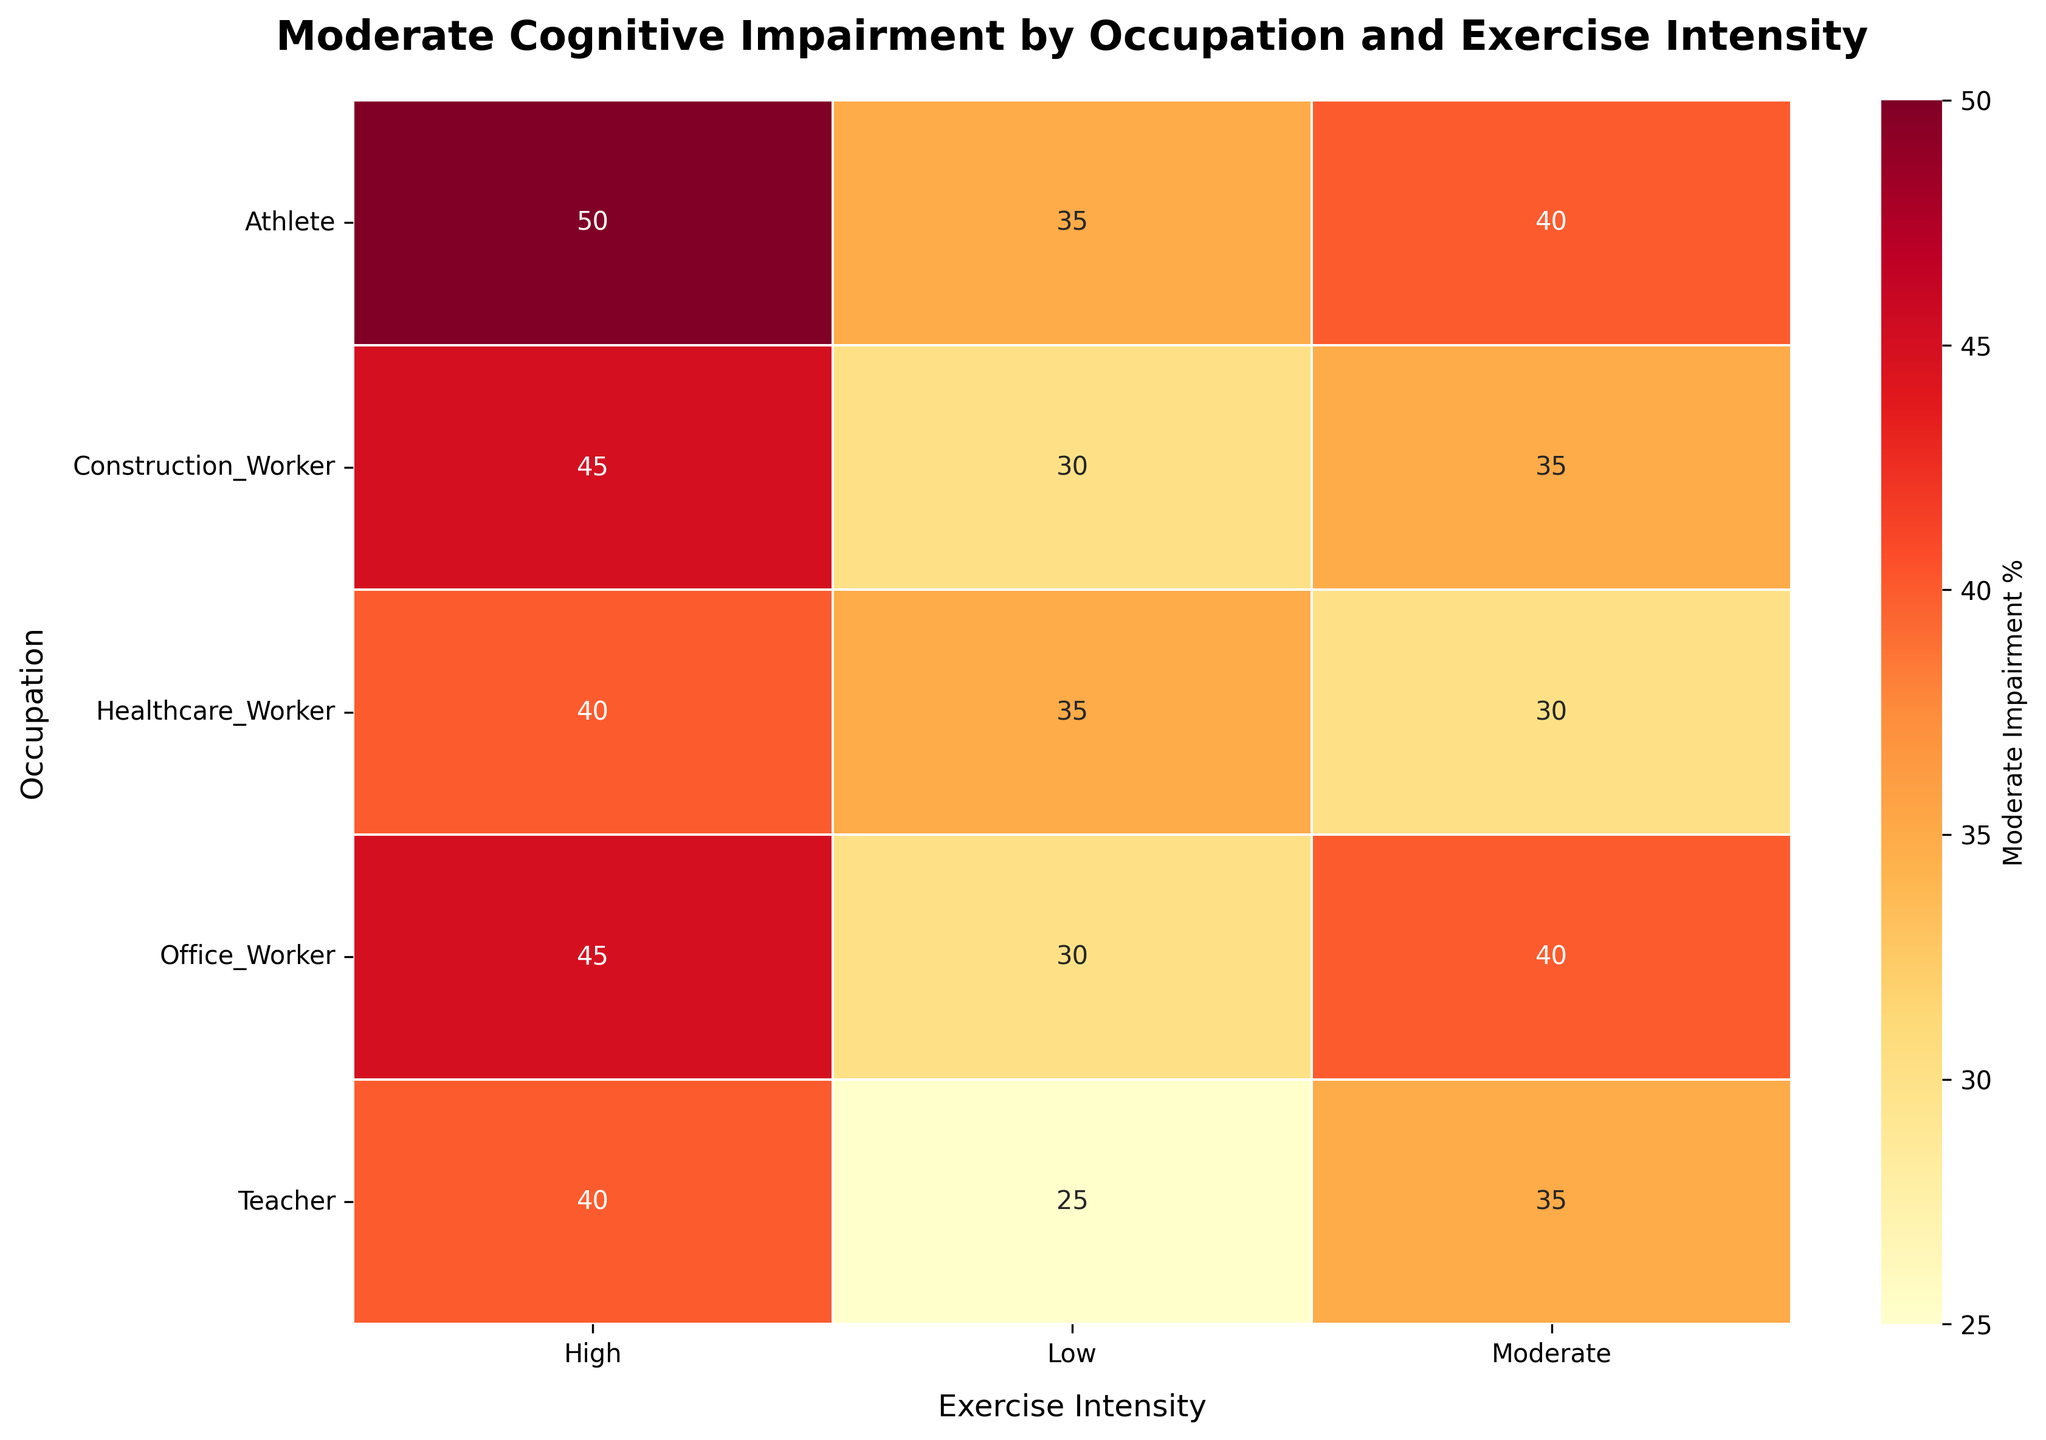what is the title of the heatmap? The title can be found at the top of the heatmap.
Answer: Moderate Cognitive Impairment by Occupation and Exercise Intensity which occupation has the highest percentage of Moderate cognitive impairment with moderate exercise intensity? Look across the 'Moderate' column and identify the cell with the highest percentage.
Answer: Office_Worker (40%) does the exercise intensity impact the moderate impairment percentage for Healthcare_Workers? Compare the percentages in the Healthcare_Worker row across Low, Moderate, and High exercise intensities.
Answer: Yes, the percentages are 35%, 30%, and 40% respectively for which occupation does moderate exercise intensity result in a higher moderate impairment percentage than low exercise intensity? Compare the values in the 'Low' and 'Moderate' columns for each occupation and identify any occupations where the percentage is higher for 'Moderate' than 'Low'.
Answer: Office_Worker, Construction_Worker which occupation and exercise intensity combination has the lowest moderate impairment percentage? Scan through the entire heatmap to identify the cell with the lowest percentage.
Answer: Teacher with High exercise intensity (15%) how does the moderate impairment percentage of Healthcare_Workers with high exercise intensity compare to Athletes with high exercise intensity? Compare the values in the 'High' column for Healthcare_Worker and Athlete rows.
Answer: Healthcare_Worker: 40%, Athlete: 50%. So, Healthcare_Workers have a lower percentage what is the average moderate impairment percentage for Teachers across all exercise intensities? Add the moderate impairment percentages for Teachers and divide by the number of exercise intensities (3). (25 + 35 + 40)/3
Answer: 33.3% which occupation shows the smallest variation in moderate impairment percentage across different exercise intensities? Calculate the range (difference between the highest and lowest percentages) for each occupation and identify the smallest.
Answer: Teacher (40-25=15%) are there more moderate impairment percentages in the range of 30-40 or 40-50? Count the cells with percentages in the ranges 30-40 and 40-50 across the entire heatmap.
Answer: 30-40 range: 7, 40-50 range: 5 does any occupation have the same moderate impairment percentage for different exercise intensities? Scan through each row to see if any percentages repeat for different exercise intensities.
Answer: No, all percentages are unique across different exercise intensities for each occupation 